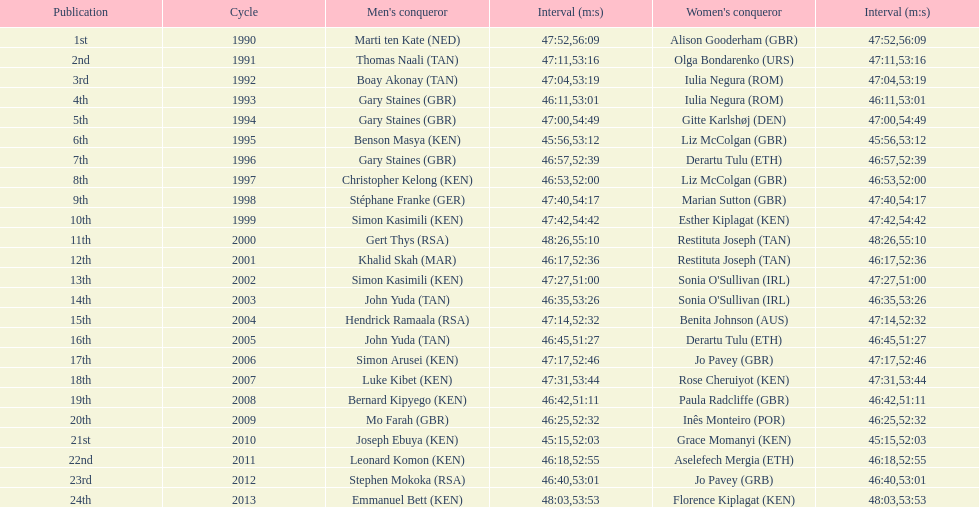Where any women faster than any men? No. 